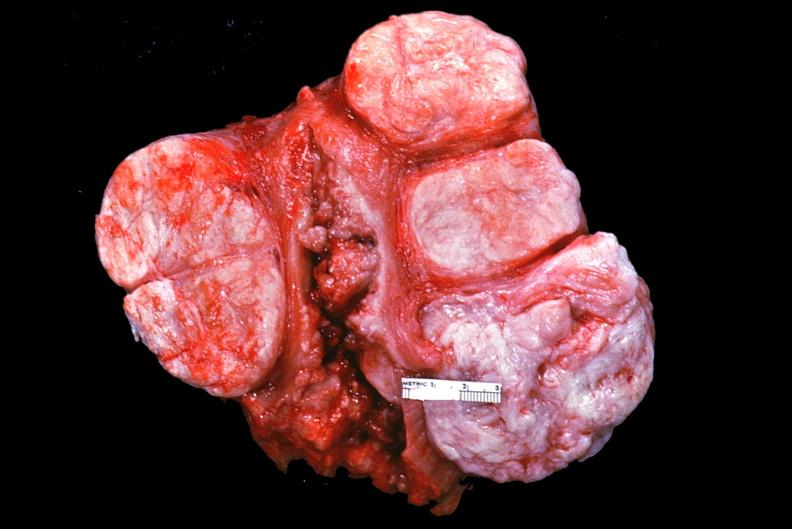what does this image show?
Answer the question using a single word or phrase. Uterus 